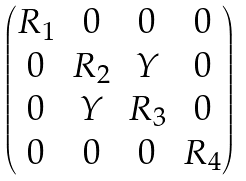Convert formula to latex. <formula><loc_0><loc_0><loc_500><loc_500>\begin{pmatrix} R _ { 1 } & 0 & 0 & 0 \\ 0 & R _ { 2 } & Y & 0 \\ 0 & Y & R _ { 3 } & 0 \\ 0 & 0 & 0 & R _ { 4 } \end{pmatrix}</formula> 